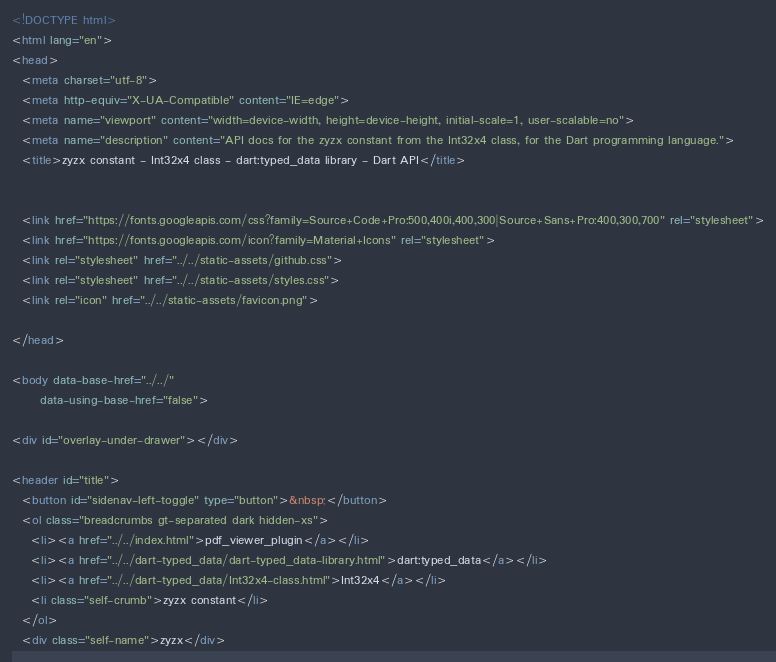<code> <loc_0><loc_0><loc_500><loc_500><_HTML_><!DOCTYPE html>
<html lang="en">
<head>
  <meta charset="utf-8">
  <meta http-equiv="X-UA-Compatible" content="IE=edge">
  <meta name="viewport" content="width=device-width, height=device-height, initial-scale=1, user-scalable=no">
  <meta name="description" content="API docs for the zyzx constant from the Int32x4 class, for the Dart programming language.">
  <title>zyzx constant - Int32x4 class - dart:typed_data library - Dart API</title>

  
  <link href="https://fonts.googleapis.com/css?family=Source+Code+Pro:500,400i,400,300|Source+Sans+Pro:400,300,700" rel="stylesheet">
  <link href="https://fonts.googleapis.com/icon?family=Material+Icons" rel="stylesheet">
  <link rel="stylesheet" href="../../static-assets/github.css">
  <link rel="stylesheet" href="../../static-assets/styles.css">
  <link rel="icon" href="../../static-assets/favicon.png">

</head>

<body data-base-href="../../"
      data-using-base-href="false">

<div id="overlay-under-drawer"></div>

<header id="title">
  <button id="sidenav-left-toggle" type="button">&nbsp;</button>
  <ol class="breadcrumbs gt-separated dark hidden-xs">
    <li><a href="../../index.html">pdf_viewer_plugin</a></li>
    <li><a href="../../dart-typed_data/dart-typed_data-library.html">dart:typed_data</a></li>
    <li><a href="../../dart-typed_data/Int32x4-class.html">Int32x4</a></li>
    <li class="self-crumb">zyzx constant</li>
  </ol>
  <div class="self-name">zyzx</div></code> 